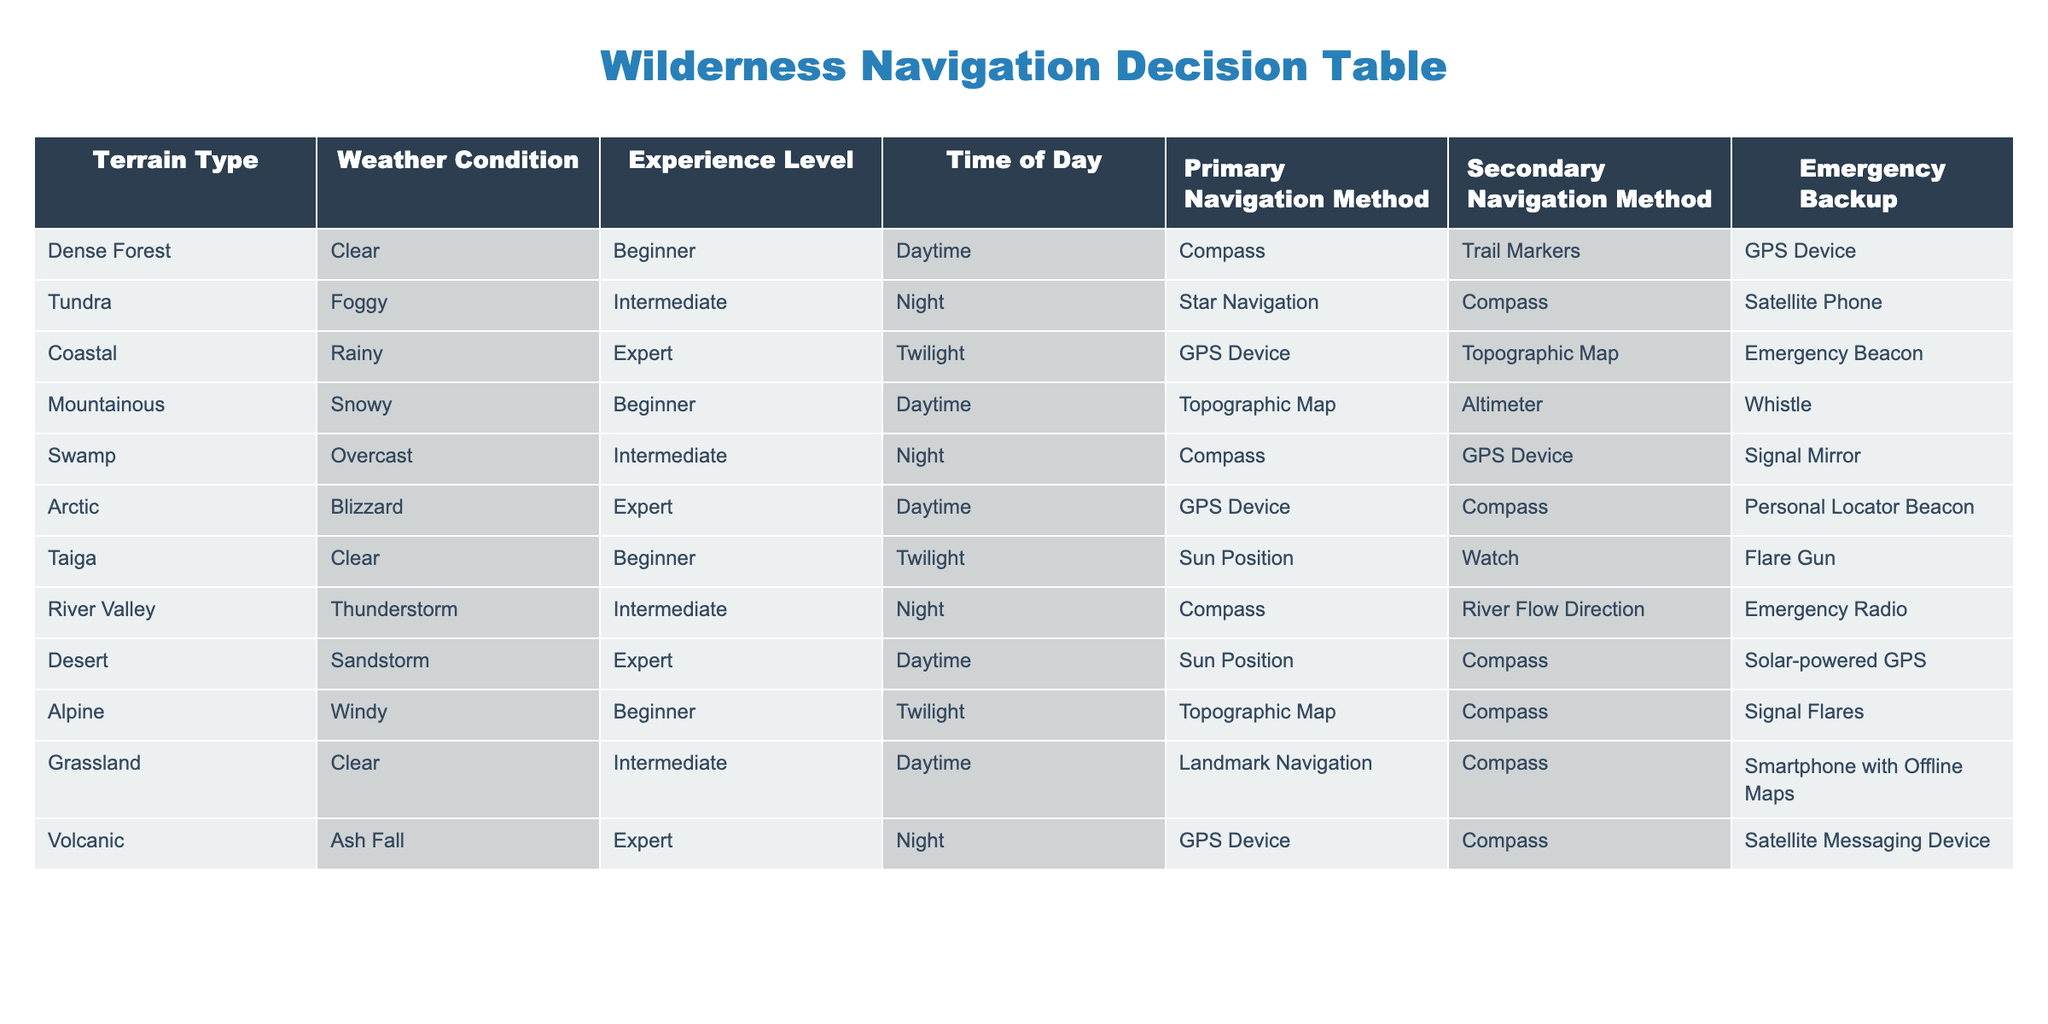What primary navigation method is used in a dense forest during the daytime by beginners? In the table, locate the row for "Dense Forest" where the "Experience Level" is "Beginner" and the "Time of Day" is "Daytime." The corresponding "Primary Navigation Method" noted in that row is "Compass."
Answer: Compass How many primary navigation methods are listed for expert experience level? Count the rows in the table that have "Expert" in the "Experience Level" column. There are three relevant rows: Coastal, Arctic, and Volcanic, each with a different primary navigation method.
Answer: Three Is the emergency backup method always a GPS device in the table? Review the "Emergency Backup" column across all rows. Not all methods listed are GPS devices; there are other options like "Whistle," "Signal Mirror," and "Personal Locator Beacon." Hence, the answer is no.
Answer: No What is the secondary navigation method when navigating in the tundra at night? Find the row in the table for "Tundra," where the "Time of Day" is "Night." The corresponding "Secondary Navigation Method" in that row is "Compass."
Answer: Compass For which terrain type is "Star Navigation" the primary method? Look specifically at the rows to identify "Star Navigation." The only terrain type with "Star Navigation" as the primary method is "Tundra" at night.
Answer: Tundra If you were to average the terrain types listed for beginners, what would be the resulting range of navigation methods? Assess the rows for "Beginner" experience level: Dense Forest, Mountainous, Taiga, and Alpine. They have a total of 4 different primary navigation methods: Compass, Topographic Map, Sun Position, and Topographic Map. The unique methods are 3 in total when excluding duplicates (Compass, Topographic Map, Sun Position).
Answer: 3 unique methods Do any intermediate navigation techniques utilize a GPS device? Check the rows with "Intermediate" as the experience level. The rows for Swamp and Grassland both list "GPS Device" as a secondary method. Since it is present, the answer is yes.
Answer: Yes Which navigation technique is used in a swamp at night? Navigate to the row that indicates "Swamp" and "Night." According to the table, the "Primary Navigation Method" is "Compass."
Answer: Compass How does the secondary navigation method in coastal terrain differ from that in a desert environment? Compare the coastal row and the desert row. For coastal, the secondary method is "Topographic Map," whereas for the desert, it is "Compass." This indicates a difference in navigational techniques due to terrain variations.
Answer: It differs: Topographic Map vs. Compass 